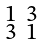Convert formula to latex. <formula><loc_0><loc_0><loc_500><loc_500>\begin{smallmatrix} 1 & 3 \\ 3 & 1 \end{smallmatrix}</formula> 